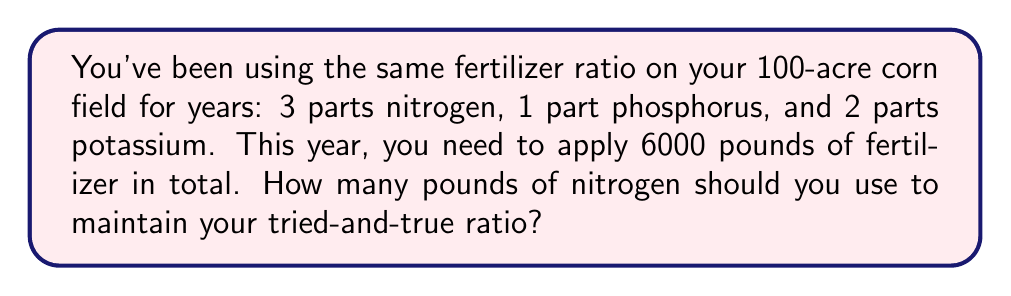Could you help me with this problem? Let's approach this step-by-step:

1) First, let's identify the ratio of the fertilizer components:
   Nitrogen : Phosphorus : Potassium = 3 : 1 : 2

2) To find the total parts in the ratio, we add these numbers:
   $3 + 1 + 2 = 6$ total parts

3) We know that the total amount of fertilizer is 6000 pounds. Let's set up a proportion:
   
   $$\frac{6 \text{ parts}}{6000 \text{ pounds}} = \frac{3 \text{ parts nitrogen}}{x \text{ pounds nitrogen}}$$

4) Cross multiply:
   $6x = 3 \cdot 6000$

5) Solve for $x$:
   $x = \frac{3 \cdot 6000}{6} = 3000$

Therefore, to maintain your traditional ratio, you should use 3000 pounds of nitrogen.
Answer: 3000 pounds 